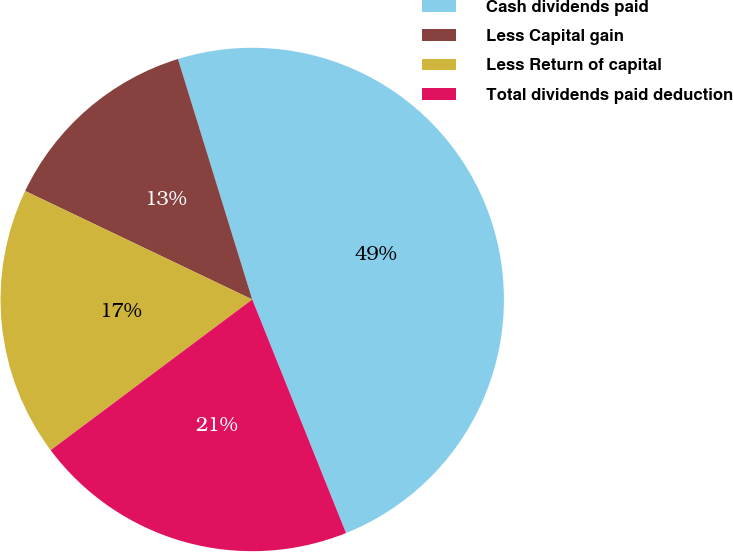Convert chart. <chart><loc_0><loc_0><loc_500><loc_500><pie_chart><fcel>Cash dividends paid<fcel>Less Capital gain<fcel>Less Return of capital<fcel>Total dividends paid deduction<nl><fcel>48.69%<fcel>13.14%<fcel>17.31%<fcel>20.86%<nl></chart> 